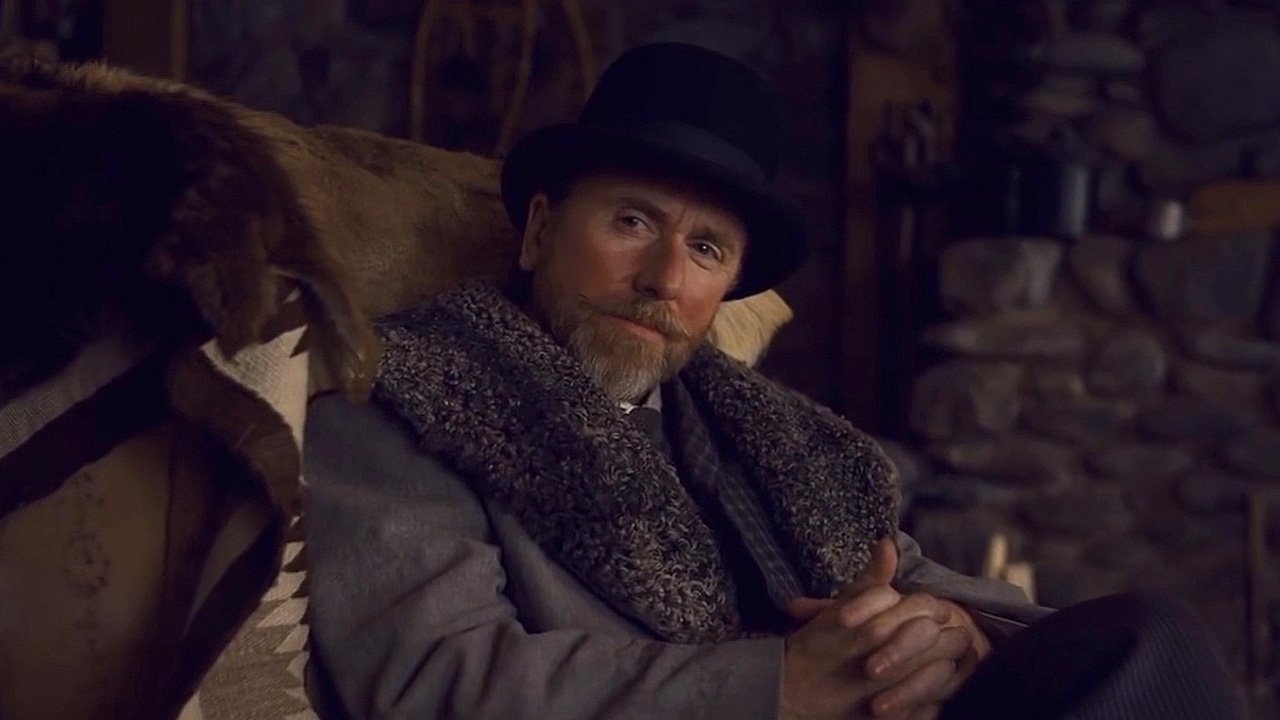Can you describe the mood or atmosphere conveyed by the setting and the man’s expression? The setting and the man's expression collectively convey a somber and reflective mood. The rustic stone wall and the thick fur lining of his coat suggest a cold environment, possibly enhancing the introspective and serious aura surrounding him. His stern expression and the dimly lit surroundings contribute to a feeling of solemnity or deep thought. 